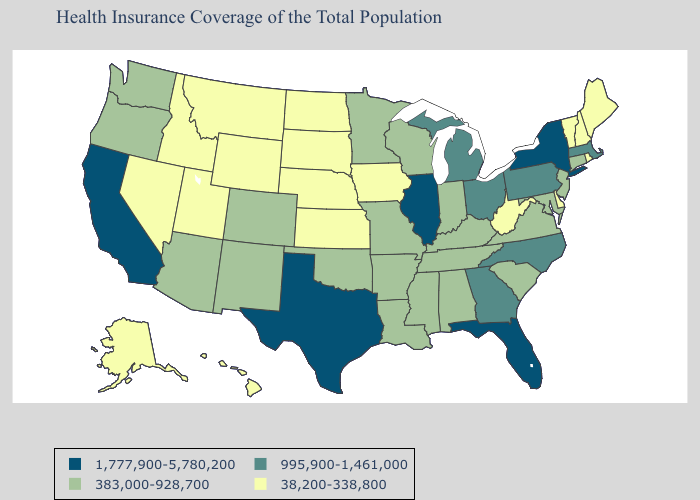What is the value of Wisconsin?
Keep it brief. 383,000-928,700. What is the value of North Dakota?
Write a very short answer. 38,200-338,800. What is the value of New Mexico?
Be succinct. 383,000-928,700. Which states hav the highest value in the Northeast?
Be succinct. New York. What is the lowest value in the West?
Write a very short answer. 38,200-338,800. Does Kansas have the highest value in the MidWest?
Quick response, please. No. What is the highest value in states that border Alabama?
Be succinct. 1,777,900-5,780,200. Which states hav the highest value in the South?
Be succinct. Florida, Texas. Name the states that have a value in the range 995,900-1,461,000?
Keep it brief. Georgia, Massachusetts, Michigan, North Carolina, Ohio, Pennsylvania. Does New York have the highest value in the USA?
Write a very short answer. Yes. What is the value of North Dakota?
Give a very brief answer. 38,200-338,800. What is the value of Virginia?
Short answer required. 383,000-928,700. Among the states that border Iowa , which have the lowest value?
Keep it brief. Nebraska, South Dakota. Does Michigan have a higher value than Pennsylvania?
Be succinct. No. Name the states that have a value in the range 995,900-1,461,000?
Give a very brief answer. Georgia, Massachusetts, Michigan, North Carolina, Ohio, Pennsylvania. 